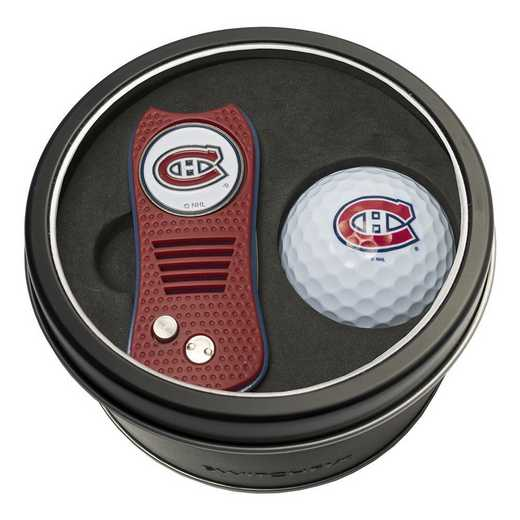What significance does the logo on these items carry, and how might this influence a buyer's decision? The logo on these items represents a specific sports club, which can be a significant factor for fans or members of this club. Sporting merchandise with this logo can serve as a symbol of support or affiliation to the club, influencing enthusiasts to purchase it to show their allegiance or as part of a collection. It might also appeal to those who have a sentimental attachment to the club, perhaps influencing their decision more than the functionality of the items themselves. 